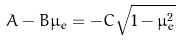<formula> <loc_0><loc_0><loc_500><loc_500>A - B \mu _ { e } = - C \sqrt { 1 - \mu _ { e } ^ { 2 } }</formula> 